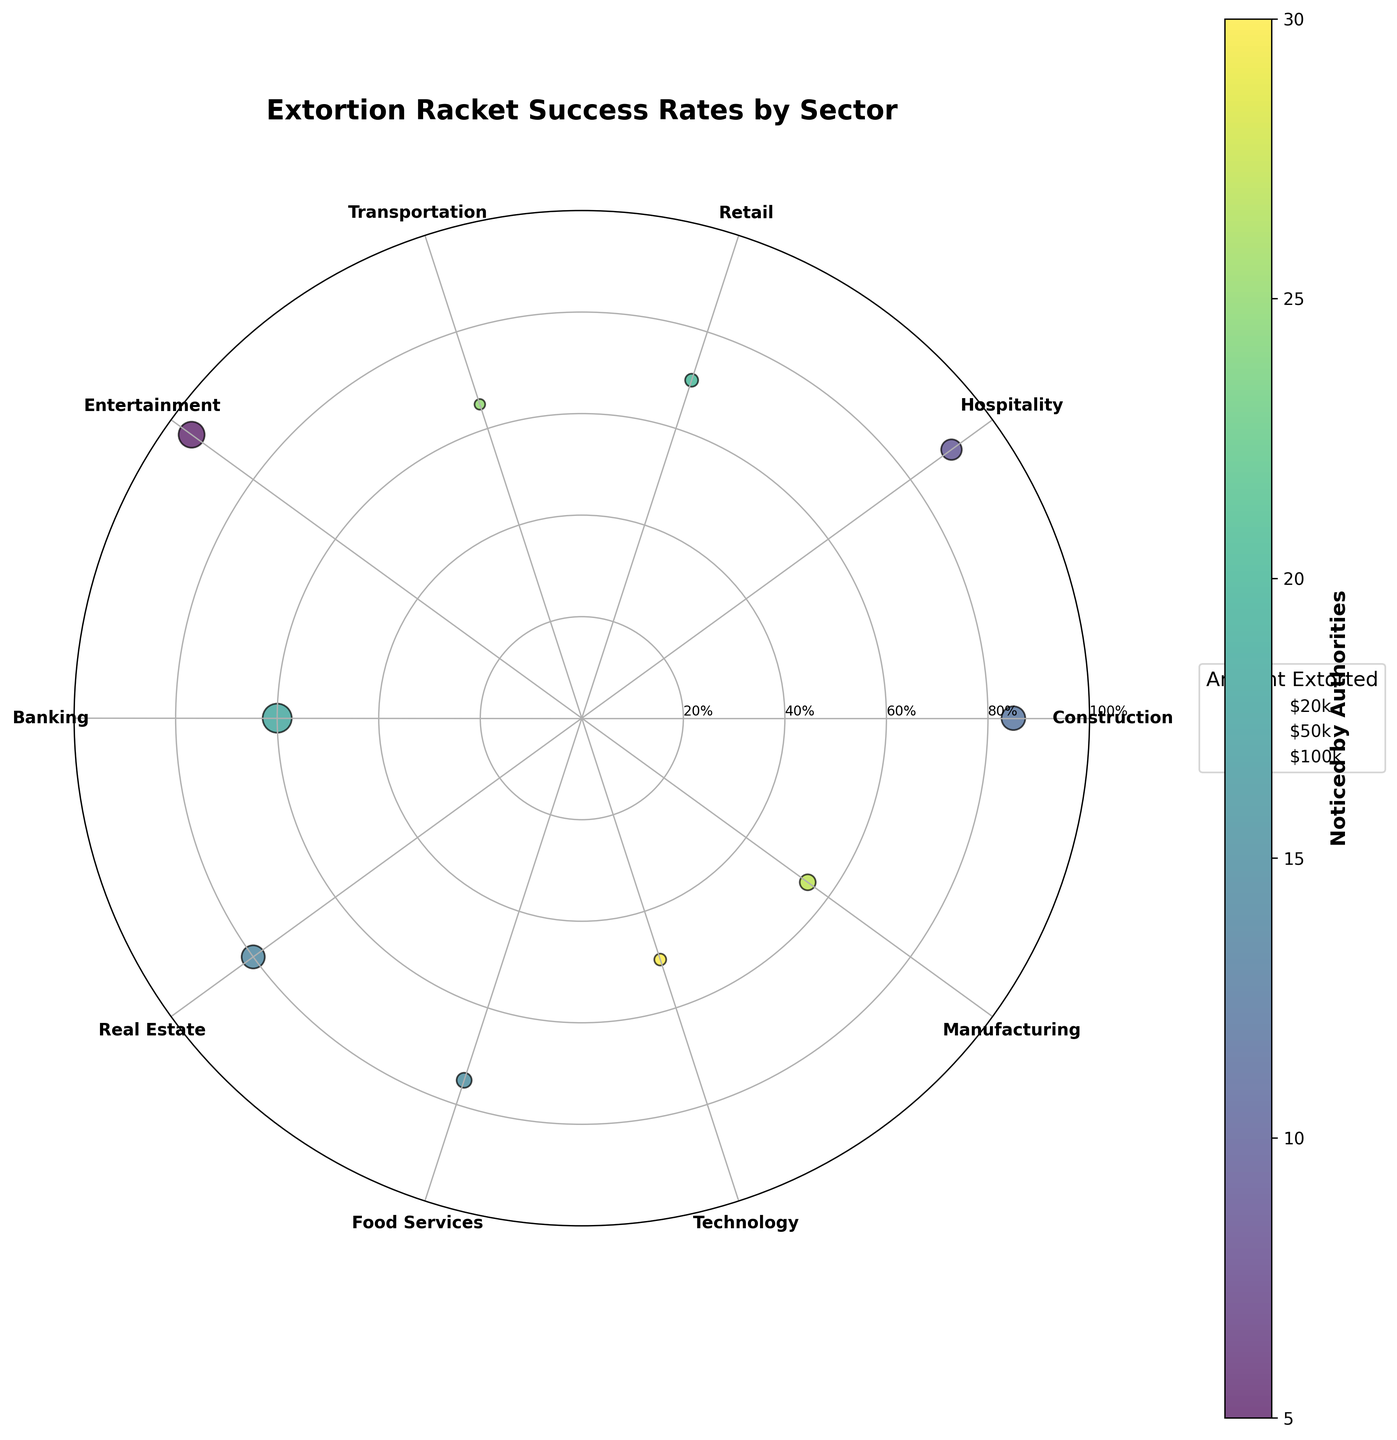What is the title of the figure? The title of the figure is usually found at the top and provides a succinct description of the data being presented.
Answer: Extortion Racket Success Rates by Sector How many sectors are represented in the chart? Counting the number of labels around the polar plot, which each represents a sector, will give the total number of sectors.
Answer: 10 Which sector has the highest success rate? Look for the sector whose scatter point is the furthest from the center, which indicates the highest success rate.
Answer: Entertainment (Nightshade Club) Which sector's racket activities are most noticed by authorities? The color gradient on the scatter points represents how noticed the sector's activities are; the one with the darkest shade represents the highest noticing rate.
Answer: Technology (Smart Solutions Inc) What amount was extorted in the Construction sector? The size of the scatter point corresponds to the amount extorted in each sector; refer to the legend to determine the exact amount.
Answer: $100,000 How does the success rate in the Hospitality sector compare to the Retail sector? Find the positions of both sectors on the plot and compare their distances from the center to determine which has a higher success rate.
Answer: Hospitality is higher than Retail What is the average amount extorted by entities in the Banking and Real Estate sectors combined? Add the extortion amounts for Banking and Real Estate, then divide by 2.
Answer: ($150,000 + $95,000)/2 = $122,500 What is the relationship between success rate and being noticed by authorities in the Technology sector? Look at the scatter point for Technology; consider its distance from the center (success rate) and its color (noticed by authorities).
Answer: Low success and highly noticed Which sector has a higher success rate, but lower awareness by authorities than the Transportation sector? Identify a sector whose scatter point is further from the center than Transportation and has a lighter color indicating lower noticing.
Answer: Retail (City Mall) What sector represents a business with a high success rate but a relatively low amount extorted? Search for a scatter point near the edge (high success rate) but small in size (low amount extorted).
Answer: Hospitality (Riverfront Hotel) 